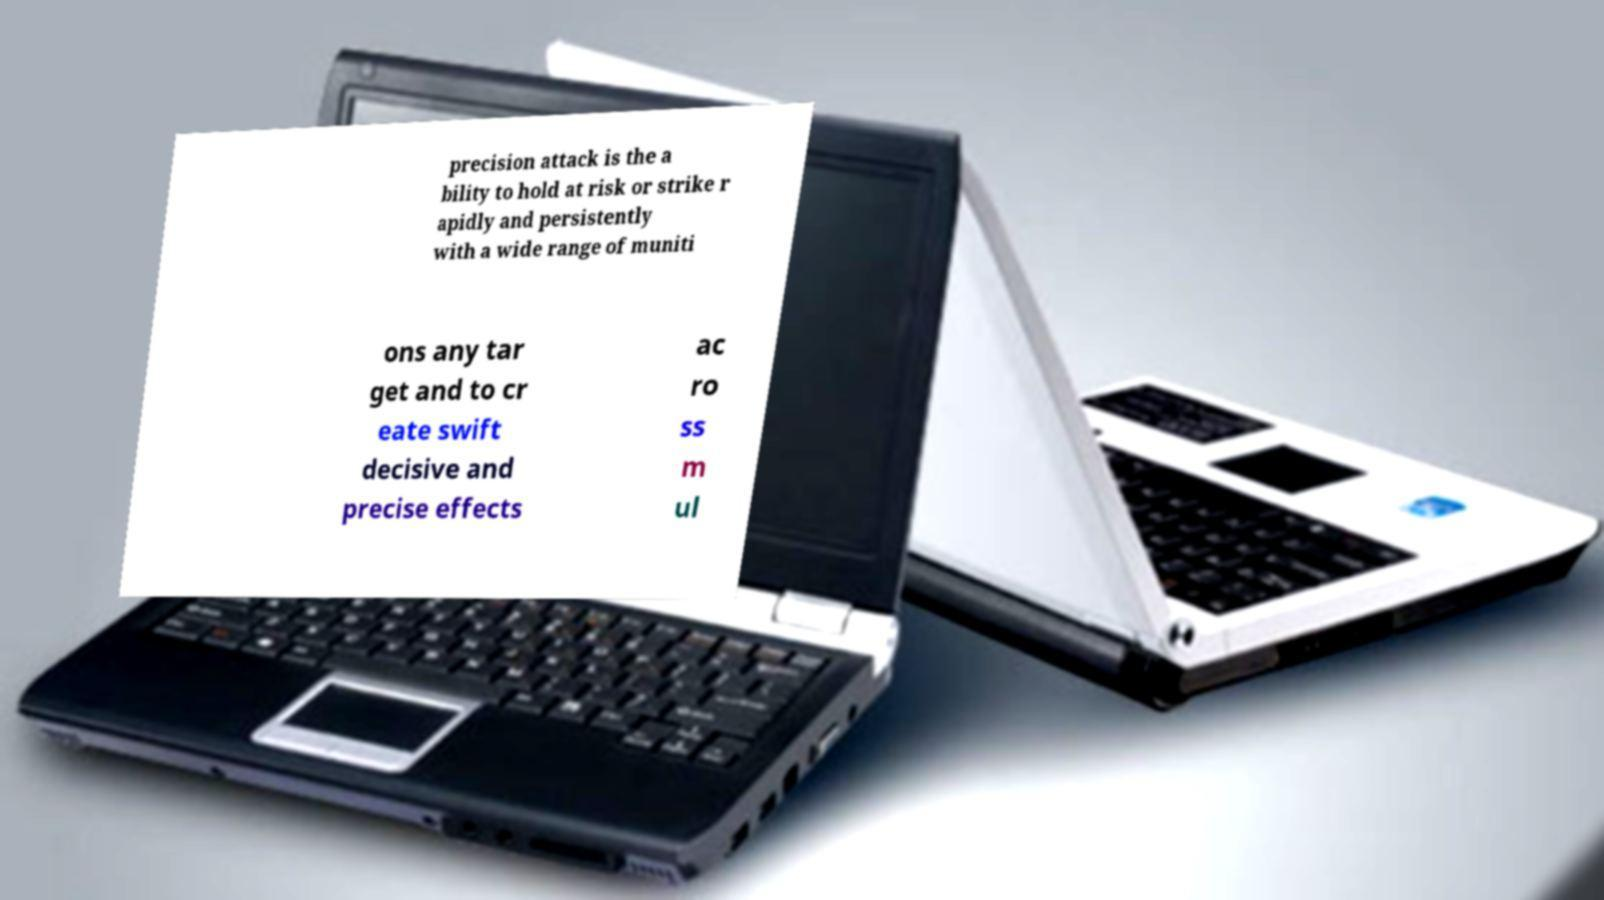Could you assist in decoding the text presented in this image and type it out clearly? precision attack is the a bility to hold at risk or strike r apidly and persistently with a wide range of muniti ons any tar get and to cr eate swift decisive and precise effects ac ro ss m ul 